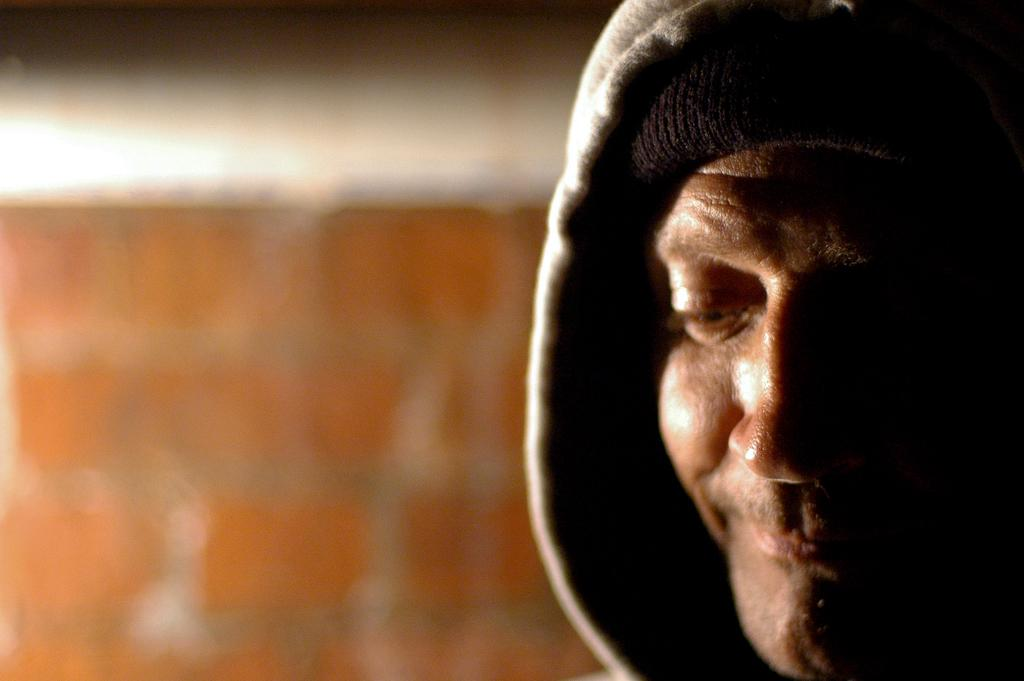What is the main subject on the right side of the image? There is a person's face on the right side of the image. Can you describe the background of the image? The background of the image is blurry. What is the income of the person in the image? There is no information about the person's income in the image. Is there any smoke visible in the image? There is no smoke present in the image. 